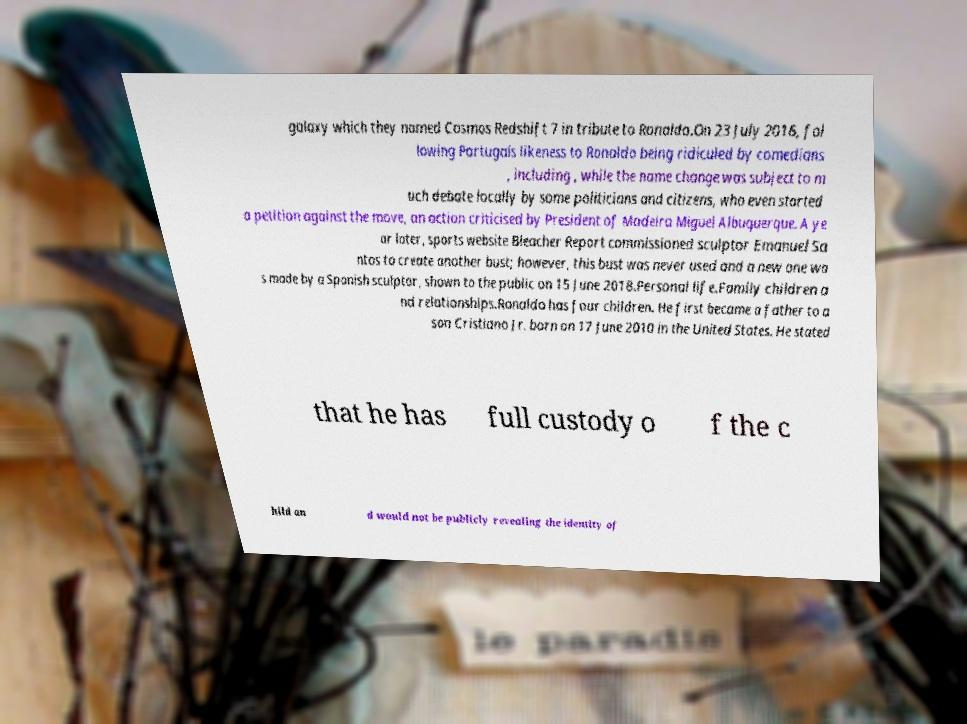There's text embedded in this image that I need extracted. Can you transcribe it verbatim? galaxy which they named Cosmos Redshift 7 in tribute to Ronaldo.On 23 July 2016, fol lowing Portugals likeness to Ronaldo being ridiculed by comedians , including , while the name change was subject to m uch debate locally by some politicians and citizens, who even started a petition against the move, an action criticised by President of Madeira Miguel Albuquerque. A ye ar later, sports website Bleacher Report commissioned sculptor Emanuel Sa ntos to create another bust; however, this bust was never used and a new one wa s made by a Spanish sculptor, shown to the public on 15 June 2018.Personal life.Family children a nd relationships.Ronaldo has four children. He first became a father to a son Cristiano Jr. born on 17 June 2010 in the United States. He stated that he has full custody o f the c hild an d would not be publicly revealing the identity of 